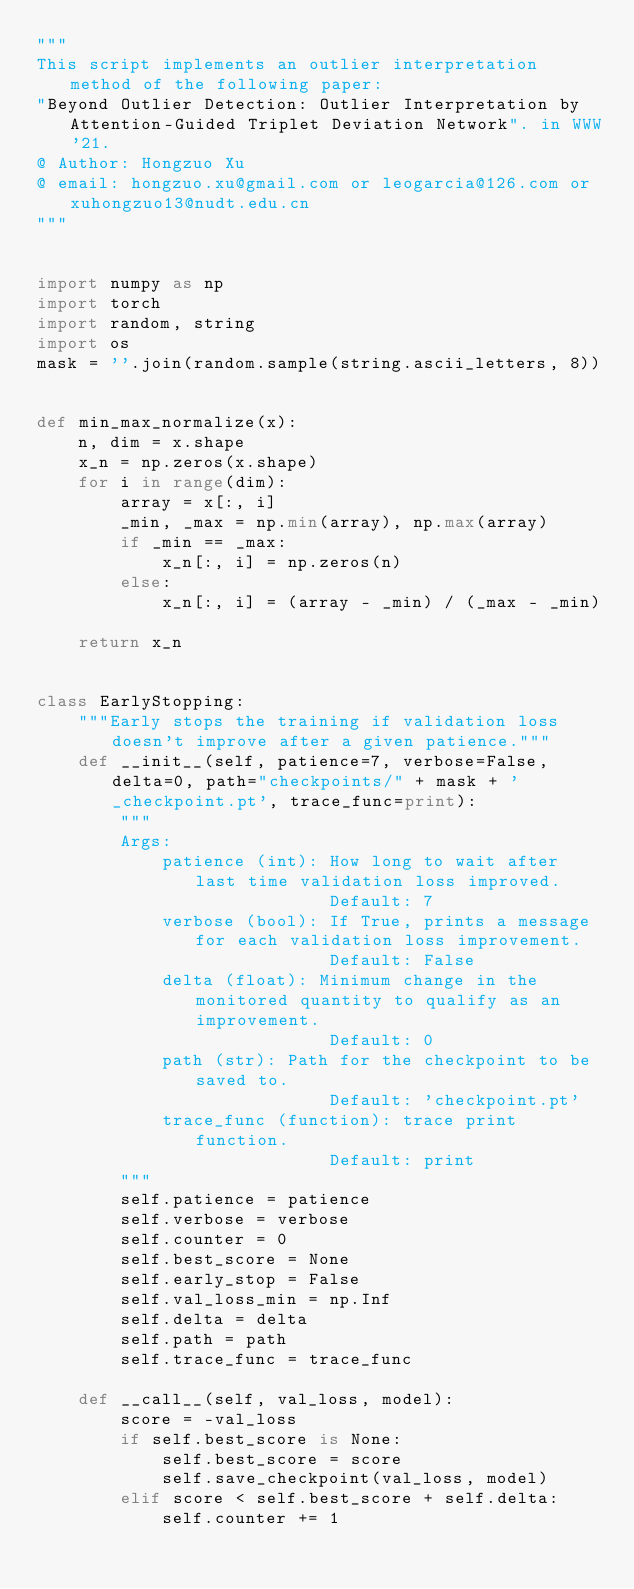<code> <loc_0><loc_0><loc_500><loc_500><_Python_>"""
This script implements an outlier interpretation method of the following paper:
"Beyond Outlier Detection: Outlier Interpretation by Attention-Guided Triplet Deviation Network". in WWW'21.
@ Author: Hongzuo Xu
@ email: hongzuo.xu@gmail.com or leogarcia@126.com or xuhongzuo13@nudt.edu.cn
"""


import numpy as np
import torch
import random, string
import os
mask = ''.join(random.sample(string.ascii_letters, 8))


def min_max_normalize(x):
    n, dim = x.shape
    x_n = np.zeros(x.shape)
    for i in range(dim):
        array = x[:, i]
        _min, _max = np.min(array), np.max(array)
        if _min == _max:
            x_n[:, i] = np.zeros(n)
        else:
            x_n[:, i] = (array - _min) / (_max - _min)

    return x_n


class EarlyStopping:
    """Early stops the training if validation loss doesn't improve after a given patience."""
    def __init__(self, patience=7, verbose=False, delta=0, path="checkpoints/" + mask + '_checkpoint.pt', trace_func=print):
        """
        Args:
            patience (int): How long to wait after last time validation loss improved.
                            Default: 7
            verbose (bool): If True, prints a message for each validation loss improvement.
                            Default: False
            delta (float): Minimum change in the monitored quantity to qualify as an improvement.
                            Default: 0
            path (str): Path for the checkpoint to be saved to.
                            Default: 'checkpoint.pt'
            trace_func (function): trace print function.
                            Default: print
        """
        self.patience = patience
        self.verbose = verbose
        self.counter = 0
        self.best_score = None
        self.early_stop = False
        self.val_loss_min = np.Inf
        self.delta = delta
        self.path = path
        self.trace_func = trace_func

    def __call__(self, val_loss, model):
        score = -val_loss
        if self.best_score is None:
            self.best_score = score
            self.save_checkpoint(val_loss, model)
        elif score < self.best_score + self.delta:
            self.counter += 1</code> 